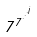Convert formula to latex. <formula><loc_0><loc_0><loc_500><loc_500>7 ^ { 7 ^ { \cdot ^ { \cdot ^ { \cdot ^ { j } } } } }</formula> 